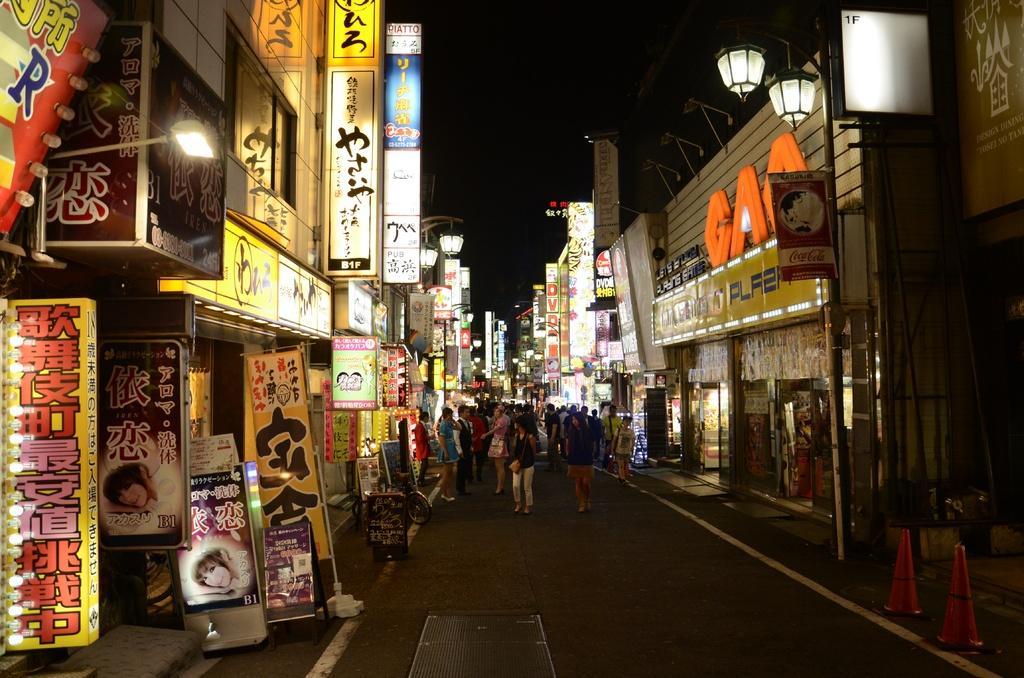Can you describe this image briefly? In the picture I can see a group of people on the road. There are buildings on the left side and the right side. I can see the LED hoarding boards. I can see the barriers on the road on the bottom right side. I can see a bicycle on the road. I can see the light poles on the side of the road. 